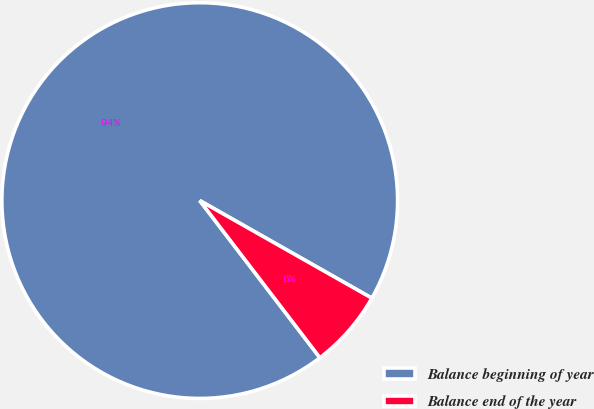Convert chart to OTSL. <chart><loc_0><loc_0><loc_500><loc_500><pie_chart><fcel>Balance beginning of year<fcel>Balance end of the year<nl><fcel>93.6%<fcel>6.4%<nl></chart> 